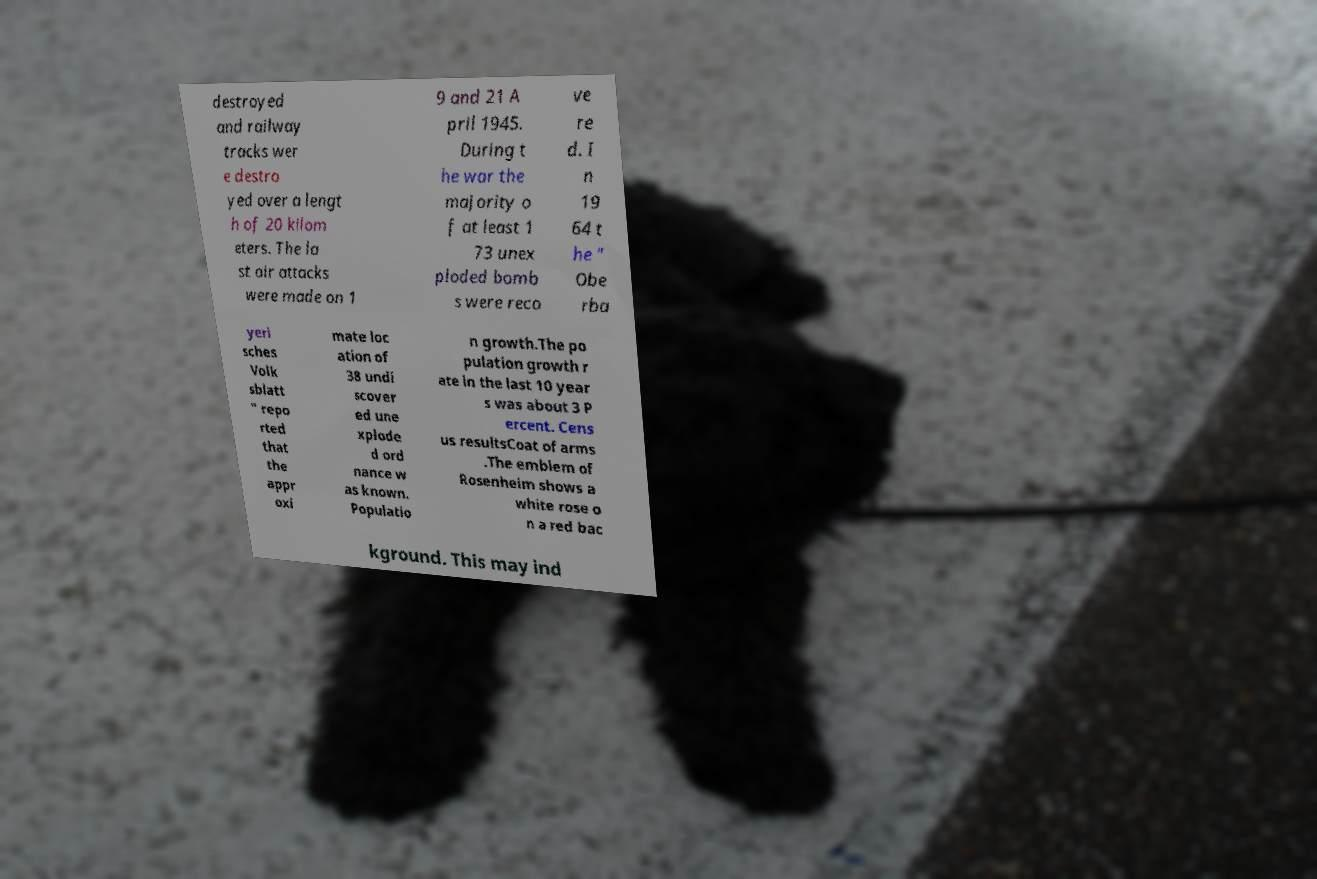Can you accurately transcribe the text from the provided image for me? destroyed and railway tracks wer e destro yed over a lengt h of 20 kilom eters. The la st air attacks were made on 1 9 and 21 A pril 1945. During t he war the majority o f at least 1 73 unex ploded bomb s were reco ve re d. I n 19 64 t he " Obe rba yeri sches Volk sblatt " repo rted that the appr oxi mate loc ation of 38 undi scover ed une xplode d ord nance w as known. Populatio n growth.The po pulation growth r ate in the last 10 year s was about 3 P ercent. Cens us resultsCoat of arms .The emblem of Rosenheim shows a white rose o n a red bac kground. This may ind 